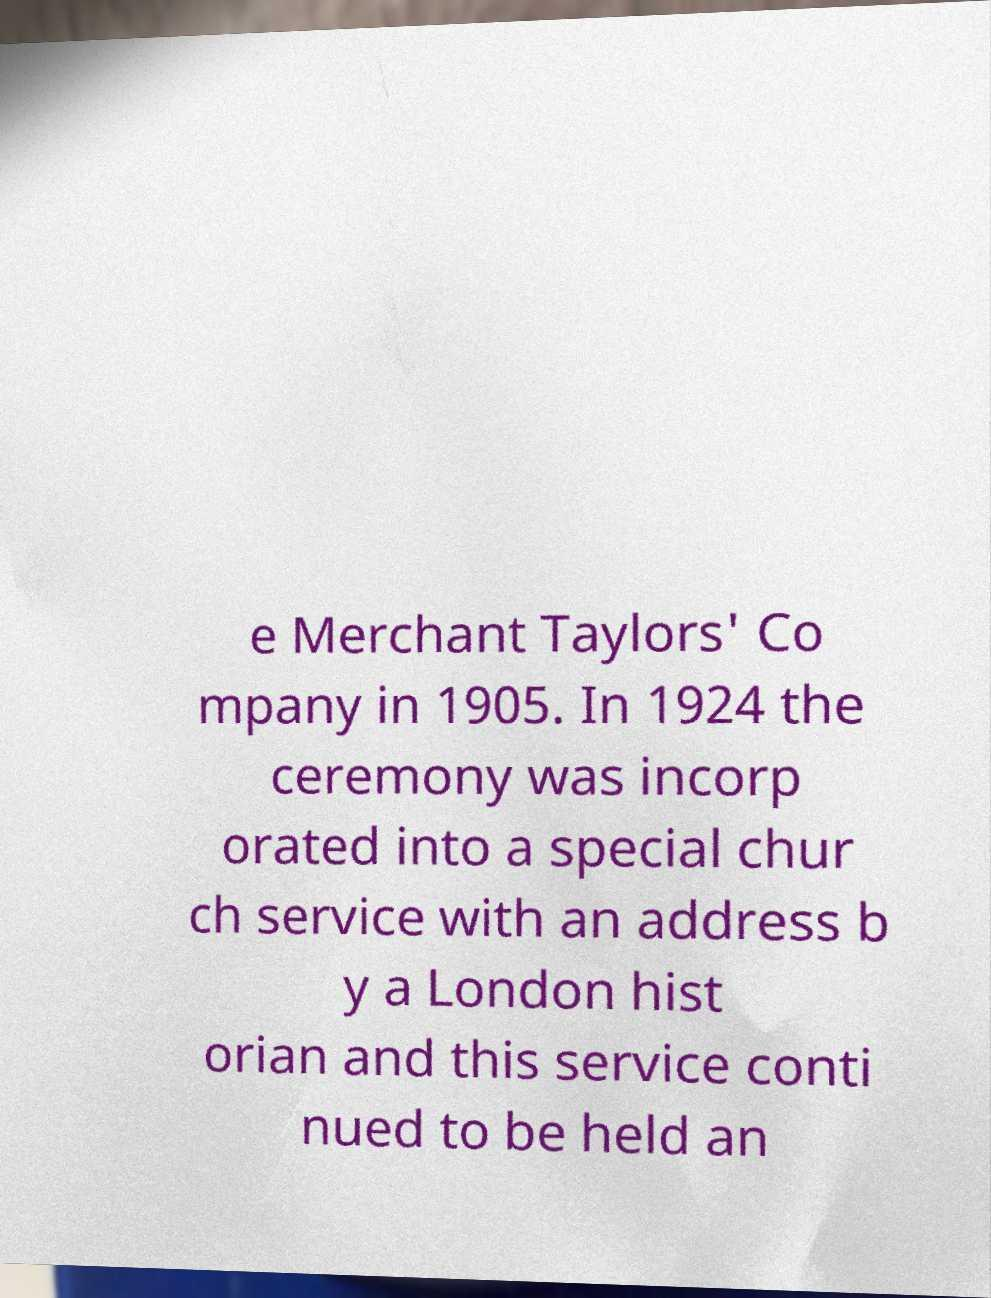Can you read and provide the text displayed in the image?This photo seems to have some interesting text. Can you extract and type it out for me? e Merchant Taylors' Co mpany in 1905. In 1924 the ceremony was incorp orated into a special chur ch service with an address b y a London hist orian and this service conti nued to be held an 